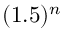<formula> <loc_0><loc_0><loc_500><loc_500>( 1 . 5 ) ^ { n }</formula> 